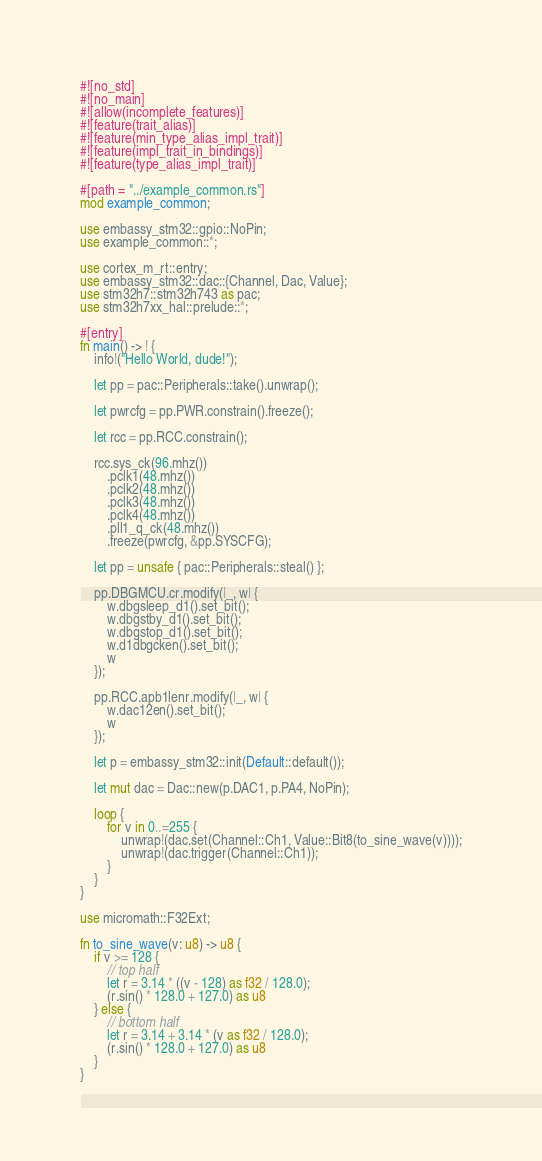Convert code to text. <code><loc_0><loc_0><loc_500><loc_500><_Rust_>#![no_std]
#![no_main]
#![allow(incomplete_features)]
#![feature(trait_alias)]
#![feature(min_type_alias_impl_trait)]
#![feature(impl_trait_in_bindings)]
#![feature(type_alias_impl_trait)]

#[path = "../example_common.rs"]
mod example_common;

use embassy_stm32::gpio::NoPin;
use example_common::*;

use cortex_m_rt::entry;
use embassy_stm32::dac::{Channel, Dac, Value};
use stm32h7::stm32h743 as pac;
use stm32h7xx_hal::prelude::*;

#[entry]
fn main() -> ! {
    info!("Hello World, dude!");

    let pp = pac::Peripherals::take().unwrap();

    let pwrcfg = pp.PWR.constrain().freeze();

    let rcc = pp.RCC.constrain();

    rcc.sys_ck(96.mhz())
        .pclk1(48.mhz())
        .pclk2(48.mhz())
        .pclk3(48.mhz())
        .pclk4(48.mhz())
        .pll1_q_ck(48.mhz())
        .freeze(pwrcfg, &pp.SYSCFG);

    let pp = unsafe { pac::Peripherals::steal() };

    pp.DBGMCU.cr.modify(|_, w| {
        w.dbgsleep_d1().set_bit();
        w.dbgstby_d1().set_bit();
        w.dbgstop_d1().set_bit();
        w.d1dbgcken().set_bit();
        w
    });

    pp.RCC.apb1lenr.modify(|_, w| {
        w.dac12en().set_bit();
        w
    });

    let p = embassy_stm32::init(Default::default());

    let mut dac = Dac::new(p.DAC1, p.PA4, NoPin);

    loop {
        for v in 0..=255 {
            unwrap!(dac.set(Channel::Ch1, Value::Bit8(to_sine_wave(v))));
            unwrap!(dac.trigger(Channel::Ch1));
        }
    }
}

use micromath::F32Ext;

fn to_sine_wave(v: u8) -> u8 {
    if v >= 128 {
        // top half
        let r = 3.14 * ((v - 128) as f32 / 128.0);
        (r.sin() * 128.0 + 127.0) as u8
    } else {
        // bottom half
        let r = 3.14 + 3.14 * (v as f32 / 128.0);
        (r.sin() * 128.0 + 127.0) as u8
    }
}
</code> 